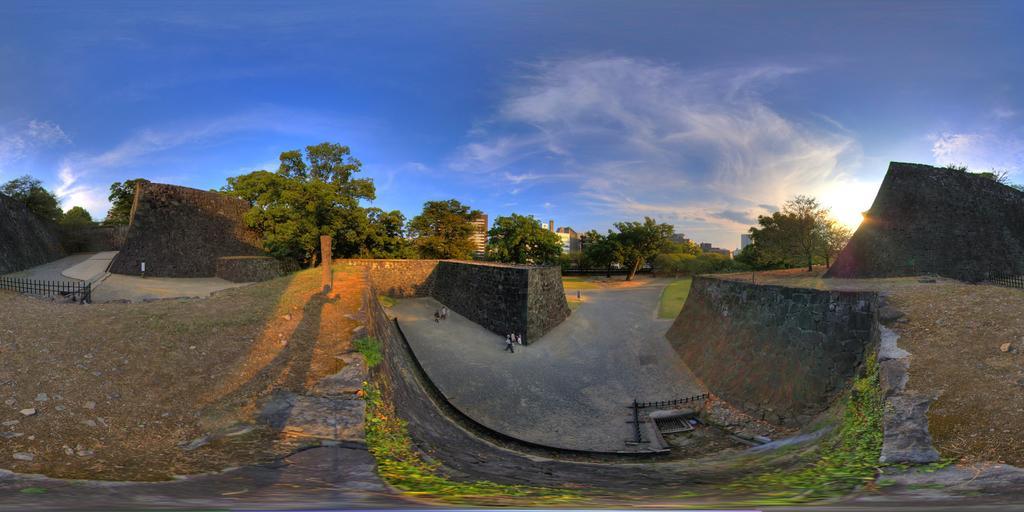In one or two sentences, can you explain what this image depicts? In the picture there is a land surface and below the surface there is an area, it is very large and there are few people walking on that area, in the background there are many trees and behind the trees there are some buildings. 